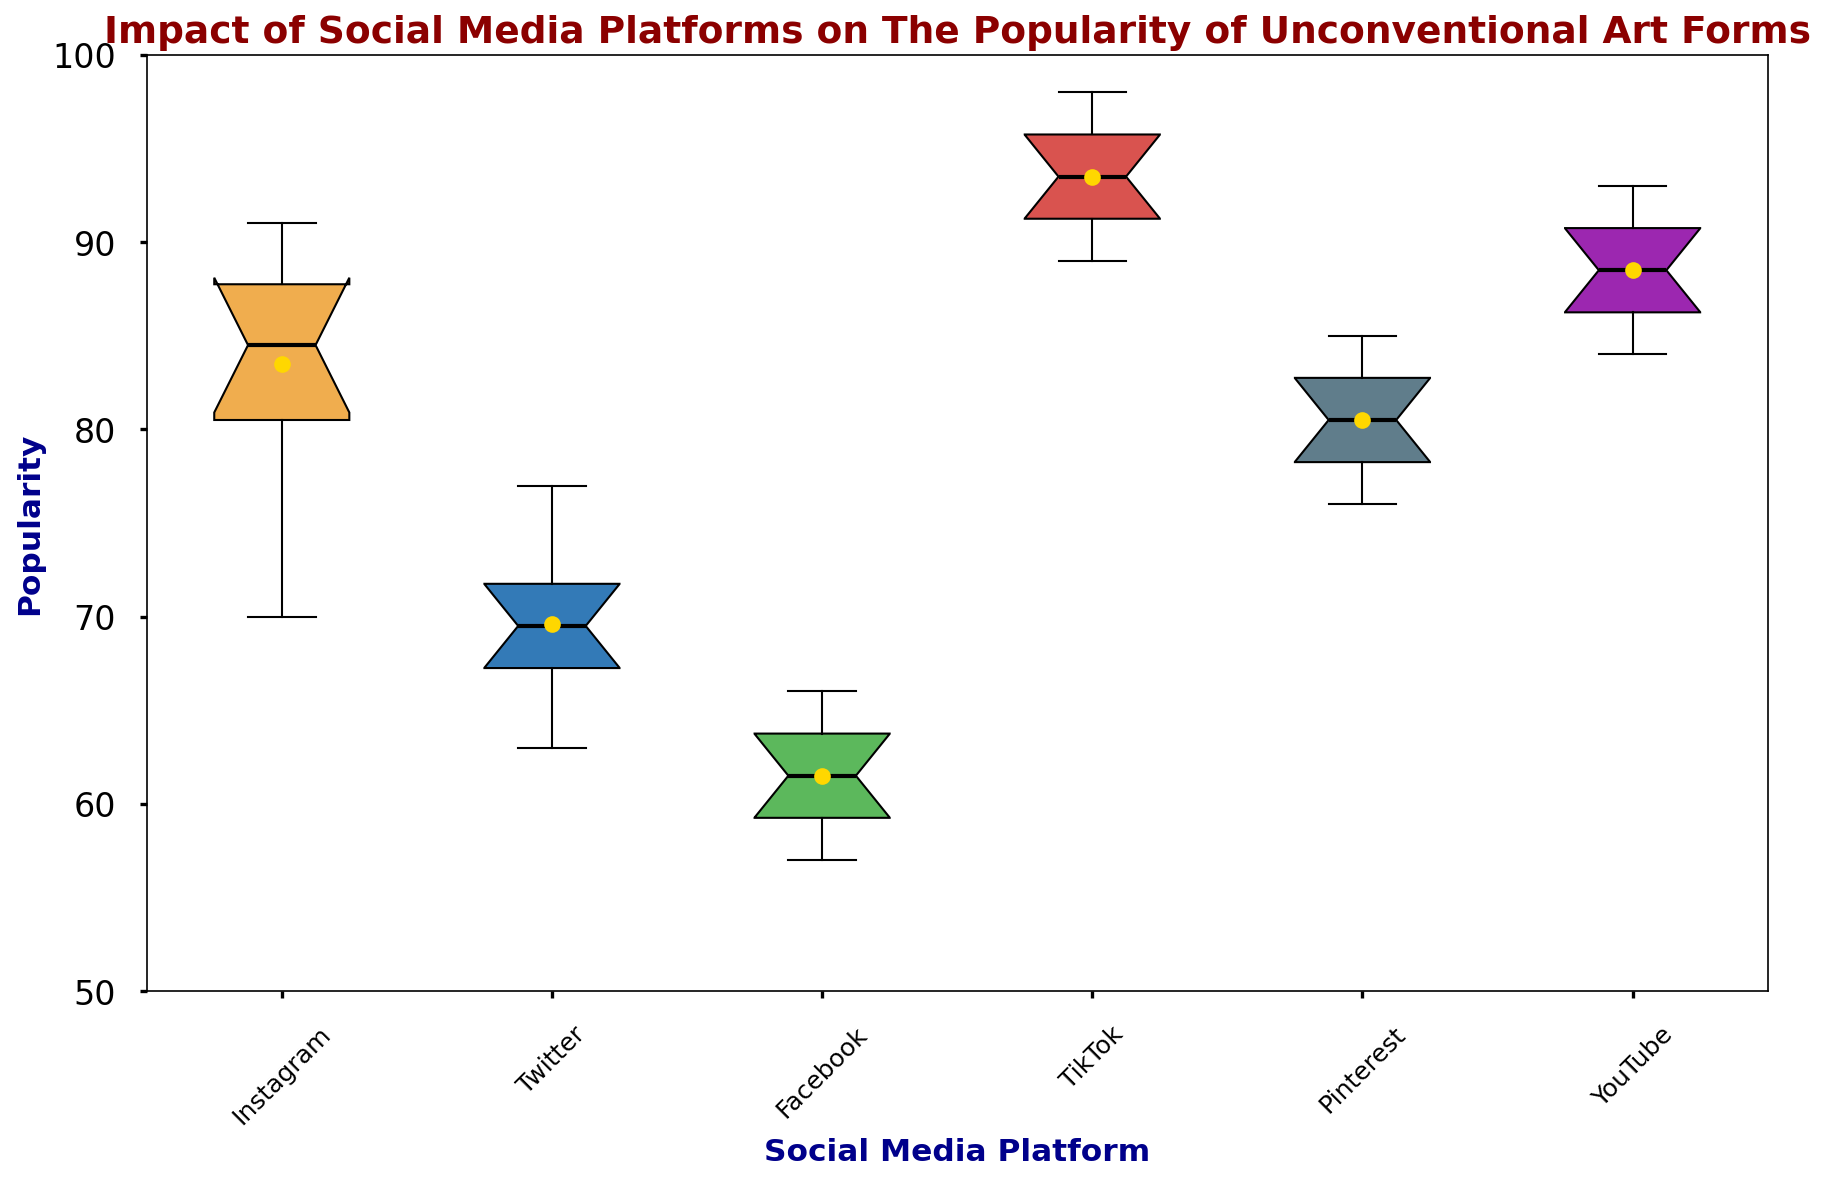Which social media platform has the highest median popularity for unconventional art forms? Look at the line inside the box for each platform. TikTok has the highest median, as the line (median) is the highest among all platforms.
Answer: TikTok Which platform shows the widest range between its minimum and maximum popularity? The range is the distance between the bottom and top whiskers. TikTok shows the widest range between 89 and 98.
Answer: TikTok What is the interquartile range (IQR) for Pinterest's popularity? The IQR is the distance between the bottom and top of the box (25th to 75th percentile). For Pinterest, the values range from about 77 to 84. The IQR is 84 - 77.
Answer: 7 Compare the mean popularity of Instagram and Facebook. Which has a higher mean? The mean is indicated by a dot inside the box. Instagram's mean is higher than Facebook's mean.
Answer: Instagram Name two platforms with similar median popularity values. Look at the lines in the middle of each box. Instagram and YouTube have similar median popularity values, both around 87.
Answer: Instagram and YouTube Which platform has the lowest maximum popularity value for unconventional art forms? The highest whisker indicates the maximum popularity. Facebook has the lowest maximum at about 66.
Answer: Facebook Which social media platform's popularity data includes an outlier? Outliers are typically shown as standalone points outside the whiskers. No platform shows outliers in this box plot.
Answer: None Which platform has the smallest interquartile range (IQR)? The smallest box indicates the smallest IQR. Facebook has the smallest IQR where the box is the smallest among all platforms.
Answer: Facebook For TikTok, what's the difference between its mean popularity and its lowest popularity? The mean is shown by the dot and the minimum is the bottom whisker for TikTok. Subtract the minimum (89) from the mean (about 93.5).
Answer: 4.5 